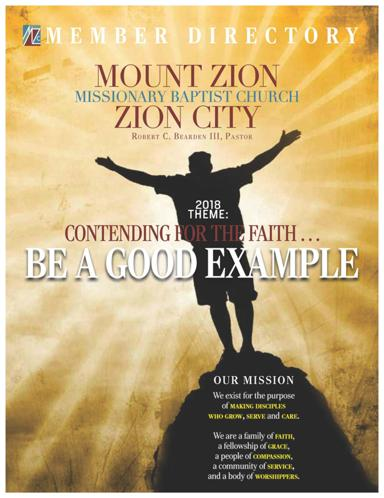Who is the pastor of the church? The leader of Mount Zion Missionary Baptist Church is Pastor Robert C. Bearden III. His guiding vision is prominently featured in the church's directory, indicating his central role in the church's activities and spiritual direction. 